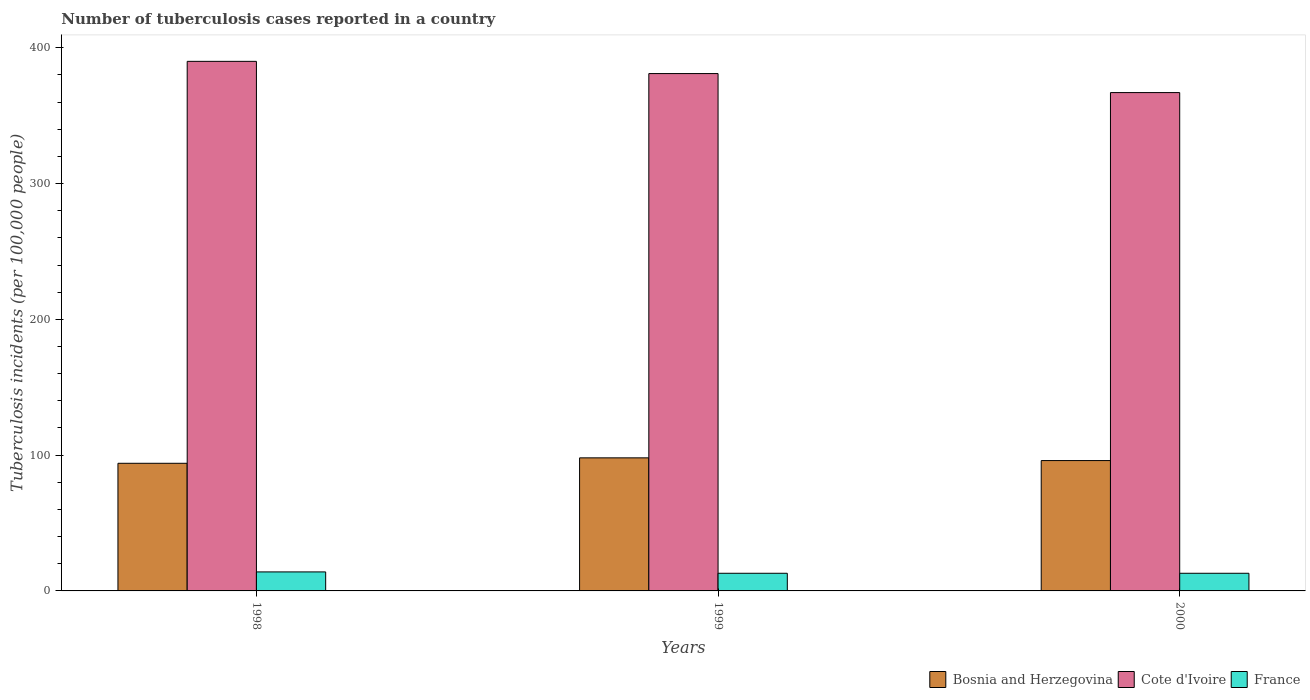How many different coloured bars are there?
Give a very brief answer. 3. How many groups of bars are there?
Ensure brevity in your answer.  3. Are the number of bars per tick equal to the number of legend labels?
Offer a very short reply. Yes. Are the number of bars on each tick of the X-axis equal?
Ensure brevity in your answer.  Yes. In how many cases, is the number of bars for a given year not equal to the number of legend labels?
Give a very brief answer. 0. Across all years, what is the maximum number of tuberculosis cases reported in in Bosnia and Herzegovina?
Offer a very short reply. 98. Across all years, what is the minimum number of tuberculosis cases reported in in Bosnia and Herzegovina?
Provide a succinct answer. 94. In which year was the number of tuberculosis cases reported in in Cote d'Ivoire maximum?
Provide a short and direct response. 1998. What is the total number of tuberculosis cases reported in in France in the graph?
Your answer should be compact. 40. What is the difference between the number of tuberculosis cases reported in in Cote d'Ivoire in 1998 and that in 2000?
Give a very brief answer. 23. What is the difference between the number of tuberculosis cases reported in in France in 2000 and the number of tuberculosis cases reported in in Bosnia and Herzegovina in 1998?
Make the answer very short. -81. What is the average number of tuberculosis cases reported in in Cote d'Ivoire per year?
Provide a succinct answer. 379.33. In the year 2000, what is the difference between the number of tuberculosis cases reported in in Cote d'Ivoire and number of tuberculosis cases reported in in Bosnia and Herzegovina?
Make the answer very short. 271. In how many years, is the number of tuberculosis cases reported in in Cote d'Ivoire greater than 180?
Provide a short and direct response. 3. What is the ratio of the number of tuberculosis cases reported in in Bosnia and Herzegovina in 1999 to that in 2000?
Your response must be concise. 1.02. Is the number of tuberculosis cases reported in in France in 1998 less than that in 2000?
Your answer should be compact. No. Is the difference between the number of tuberculosis cases reported in in Cote d'Ivoire in 1999 and 2000 greater than the difference between the number of tuberculosis cases reported in in Bosnia and Herzegovina in 1999 and 2000?
Give a very brief answer. Yes. What is the difference between the highest and the second highest number of tuberculosis cases reported in in Cote d'Ivoire?
Offer a very short reply. 9. What is the difference between the highest and the lowest number of tuberculosis cases reported in in Bosnia and Herzegovina?
Provide a succinct answer. 4. Is the sum of the number of tuberculosis cases reported in in Bosnia and Herzegovina in 1999 and 2000 greater than the maximum number of tuberculosis cases reported in in France across all years?
Ensure brevity in your answer.  Yes. What does the 3rd bar from the left in 2000 represents?
Offer a terse response. France. Is it the case that in every year, the sum of the number of tuberculosis cases reported in in France and number of tuberculosis cases reported in in Bosnia and Herzegovina is greater than the number of tuberculosis cases reported in in Cote d'Ivoire?
Offer a very short reply. No. How many bars are there?
Keep it short and to the point. 9. Does the graph contain grids?
Provide a short and direct response. No. Where does the legend appear in the graph?
Your answer should be compact. Bottom right. How are the legend labels stacked?
Give a very brief answer. Horizontal. What is the title of the graph?
Provide a succinct answer. Number of tuberculosis cases reported in a country. What is the label or title of the X-axis?
Keep it short and to the point. Years. What is the label or title of the Y-axis?
Offer a very short reply. Tuberculosis incidents (per 100,0 people). What is the Tuberculosis incidents (per 100,000 people) in Bosnia and Herzegovina in 1998?
Make the answer very short. 94. What is the Tuberculosis incidents (per 100,000 people) in Cote d'Ivoire in 1998?
Give a very brief answer. 390. What is the Tuberculosis incidents (per 100,000 people) in Cote d'Ivoire in 1999?
Provide a short and direct response. 381. What is the Tuberculosis incidents (per 100,000 people) of Bosnia and Herzegovina in 2000?
Provide a succinct answer. 96. What is the Tuberculosis incidents (per 100,000 people) of Cote d'Ivoire in 2000?
Ensure brevity in your answer.  367. What is the Tuberculosis incidents (per 100,000 people) in France in 2000?
Offer a very short reply. 13. Across all years, what is the maximum Tuberculosis incidents (per 100,000 people) in Cote d'Ivoire?
Ensure brevity in your answer.  390. Across all years, what is the minimum Tuberculosis incidents (per 100,000 people) in Bosnia and Herzegovina?
Provide a succinct answer. 94. Across all years, what is the minimum Tuberculosis incidents (per 100,000 people) in Cote d'Ivoire?
Give a very brief answer. 367. What is the total Tuberculosis incidents (per 100,000 people) of Bosnia and Herzegovina in the graph?
Give a very brief answer. 288. What is the total Tuberculosis incidents (per 100,000 people) of Cote d'Ivoire in the graph?
Your response must be concise. 1138. What is the total Tuberculosis incidents (per 100,000 people) of France in the graph?
Your response must be concise. 40. What is the difference between the Tuberculosis incidents (per 100,000 people) of Bosnia and Herzegovina in 1998 and that in 1999?
Offer a very short reply. -4. What is the difference between the Tuberculosis incidents (per 100,000 people) in Bosnia and Herzegovina in 1998 and that in 2000?
Your response must be concise. -2. What is the difference between the Tuberculosis incidents (per 100,000 people) of Bosnia and Herzegovina in 1998 and the Tuberculosis incidents (per 100,000 people) of Cote d'Ivoire in 1999?
Your answer should be very brief. -287. What is the difference between the Tuberculosis incidents (per 100,000 people) in Bosnia and Herzegovina in 1998 and the Tuberculosis incidents (per 100,000 people) in France in 1999?
Offer a very short reply. 81. What is the difference between the Tuberculosis incidents (per 100,000 people) of Cote d'Ivoire in 1998 and the Tuberculosis incidents (per 100,000 people) of France in 1999?
Make the answer very short. 377. What is the difference between the Tuberculosis incidents (per 100,000 people) of Bosnia and Herzegovina in 1998 and the Tuberculosis incidents (per 100,000 people) of Cote d'Ivoire in 2000?
Your response must be concise. -273. What is the difference between the Tuberculosis incidents (per 100,000 people) of Bosnia and Herzegovina in 1998 and the Tuberculosis incidents (per 100,000 people) of France in 2000?
Offer a terse response. 81. What is the difference between the Tuberculosis incidents (per 100,000 people) of Cote d'Ivoire in 1998 and the Tuberculosis incidents (per 100,000 people) of France in 2000?
Give a very brief answer. 377. What is the difference between the Tuberculosis incidents (per 100,000 people) of Bosnia and Herzegovina in 1999 and the Tuberculosis incidents (per 100,000 people) of Cote d'Ivoire in 2000?
Provide a short and direct response. -269. What is the difference between the Tuberculosis incidents (per 100,000 people) of Bosnia and Herzegovina in 1999 and the Tuberculosis incidents (per 100,000 people) of France in 2000?
Keep it short and to the point. 85. What is the difference between the Tuberculosis incidents (per 100,000 people) in Cote d'Ivoire in 1999 and the Tuberculosis incidents (per 100,000 people) in France in 2000?
Make the answer very short. 368. What is the average Tuberculosis incidents (per 100,000 people) of Bosnia and Herzegovina per year?
Provide a short and direct response. 96. What is the average Tuberculosis incidents (per 100,000 people) of Cote d'Ivoire per year?
Make the answer very short. 379.33. What is the average Tuberculosis incidents (per 100,000 people) of France per year?
Give a very brief answer. 13.33. In the year 1998, what is the difference between the Tuberculosis incidents (per 100,000 people) in Bosnia and Herzegovina and Tuberculosis incidents (per 100,000 people) in Cote d'Ivoire?
Give a very brief answer. -296. In the year 1998, what is the difference between the Tuberculosis incidents (per 100,000 people) in Bosnia and Herzegovina and Tuberculosis incidents (per 100,000 people) in France?
Ensure brevity in your answer.  80. In the year 1998, what is the difference between the Tuberculosis incidents (per 100,000 people) in Cote d'Ivoire and Tuberculosis incidents (per 100,000 people) in France?
Provide a succinct answer. 376. In the year 1999, what is the difference between the Tuberculosis incidents (per 100,000 people) of Bosnia and Herzegovina and Tuberculosis incidents (per 100,000 people) of Cote d'Ivoire?
Offer a terse response. -283. In the year 1999, what is the difference between the Tuberculosis incidents (per 100,000 people) of Bosnia and Herzegovina and Tuberculosis incidents (per 100,000 people) of France?
Make the answer very short. 85. In the year 1999, what is the difference between the Tuberculosis incidents (per 100,000 people) of Cote d'Ivoire and Tuberculosis incidents (per 100,000 people) of France?
Provide a short and direct response. 368. In the year 2000, what is the difference between the Tuberculosis incidents (per 100,000 people) of Bosnia and Herzegovina and Tuberculosis incidents (per 100,000 people) of Cote d'Ivoire?
Offer a very short reply. -271. In the year 2000, what is the difference between the Tuberculosis incidents (per 100,000 people) in Bosnia and Herzegovina and Tuberculosis incidents (per 100,000 people) in France?
Offer a terse response. 83. In the year 2000, what is the difference between the Tuberculosis incidents (per 100,000 people) in Cote d'Ivoire and Tuberculosis incidents (per 100,000 people) in France?
Ensure brevity in your answer.  354. What is the ratio of the Tuberculosis incidents (per 100,000 people) of Bosnia and Herzegovina in 1998 to that in 1999?
Give a very brief answer. 0.96. What is the ratio of the Tuberculosis incidents (per 100,000 people) of Cote d'Ivoire in 1998 to that in 1999?
Ensure brevity in your answer.  1.02. What is the ratio of the Tuberculosis incidents (per 100,000 people) in France in 1998 to that in 1999?
Give a very brief answer. 1.08. What is the ratio of the Tuberculosis incidents (per 100,000 people) of Bosnia and Herzegovina in 1998 to that in 2000?
Make the answer very short. 0.98. What is the ratio of the Tuberculosis incidents (per 100,000 people) of Cote d'Ivoire in 1998 to that in 2000?
Your answer should be very brief. 1.06. What is the ratio of the Tuberculosis incidents (per 100,000 people) in Bosnia and Herzegovina in 1999 to that in 2000?
Your response must be concise. 1.02. What is the ratio of the Tuberculosis incidents (per 100,000 people) in Cote d'Ivoire in 1999 to that in 2000?
Provide a succinct answer. 1.04. What is the ratio of the Tuberculosis incidents (per 100,000 people) in France in 1999 to that in 2000?
Offer a terse response. 1. What is the difference between the highest and the second highest Tuberculosis incidents (per 100,000 people) in Cote d'Ivoire?
Your response must be concise. 9. What is the difference between the highest and the second highest Tuberculosis incidents (per 100,000 people) in France?
Offer a very short reply. 1. What is the difference between the highest and the lowest Tuberculosis incidents (per 100,000 people) of Bosnia and Herzegovina?
Your answer should be compact. 4. What is the difference between the highest and the lowest Tuberculosis incidents (per 100,000 people) in Cote d'Ivoire?
Provide a succinct answer. 23. What is the difference between the highest and the lowest Tuberculosis incidents (per 100,000 people) of France?
Your answer should be very brief. 1. 